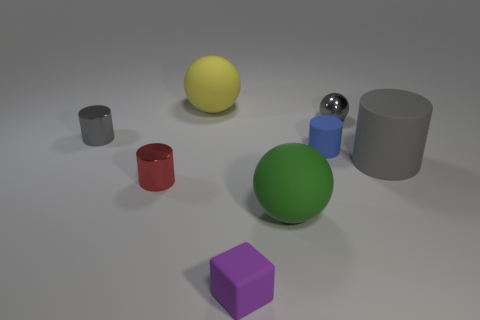Subtract all large matte spheres. How many spheres are left? 1 Subtract all gray cylinders. How many cylinders are left? 2 Subtract all spheres. How many objects are left? 5 Add 2 big yellow rubber spheres. How many objects exist? 10 Subtract 2 cylinders. How many cylinders are left? 2 Subtract all cyan cylinders. How many gray balls are left? 1 Subtract all small purple blocks. Subtract all purple objects. How many objects are left? 6 Add 8 red objects. How many red objects are left? 9 Add 3 large blue shiny blocks. How many large blue shiny blocks exist? 3 Subtract 1 green balls. How many objects are left? 7 